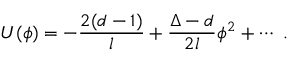<formula> <loc_0><loc_0><loc_500><loc_500>U ( \phi ) = - \frac { 2 ( d - 1 ) } l + \frac { \Delta - d } { 2 l } \phi ^ { 2 } + \cdots .</formula> 